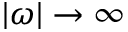<formula> <loc_0><loc_0><loc_500><loc_500>| \omega | \rightarrow \infty</formula> 